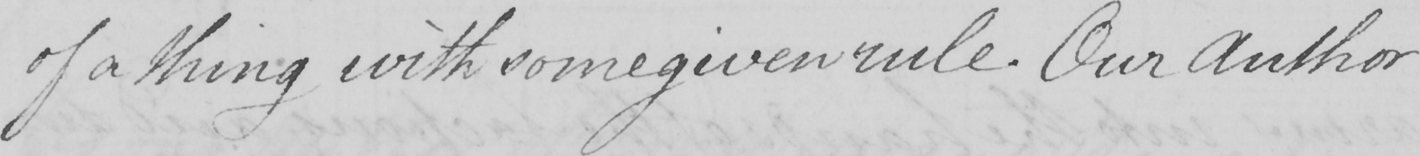Can you read and transcribe this handwriting? of a thing with some given rule . Our Author 